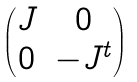<formula> <loc_0><loc_0><loc_500><loc_500>\begin{pmatrix} J & 0 \\ 0 & - J ^ { t } \end{pmatrix}</formula> 